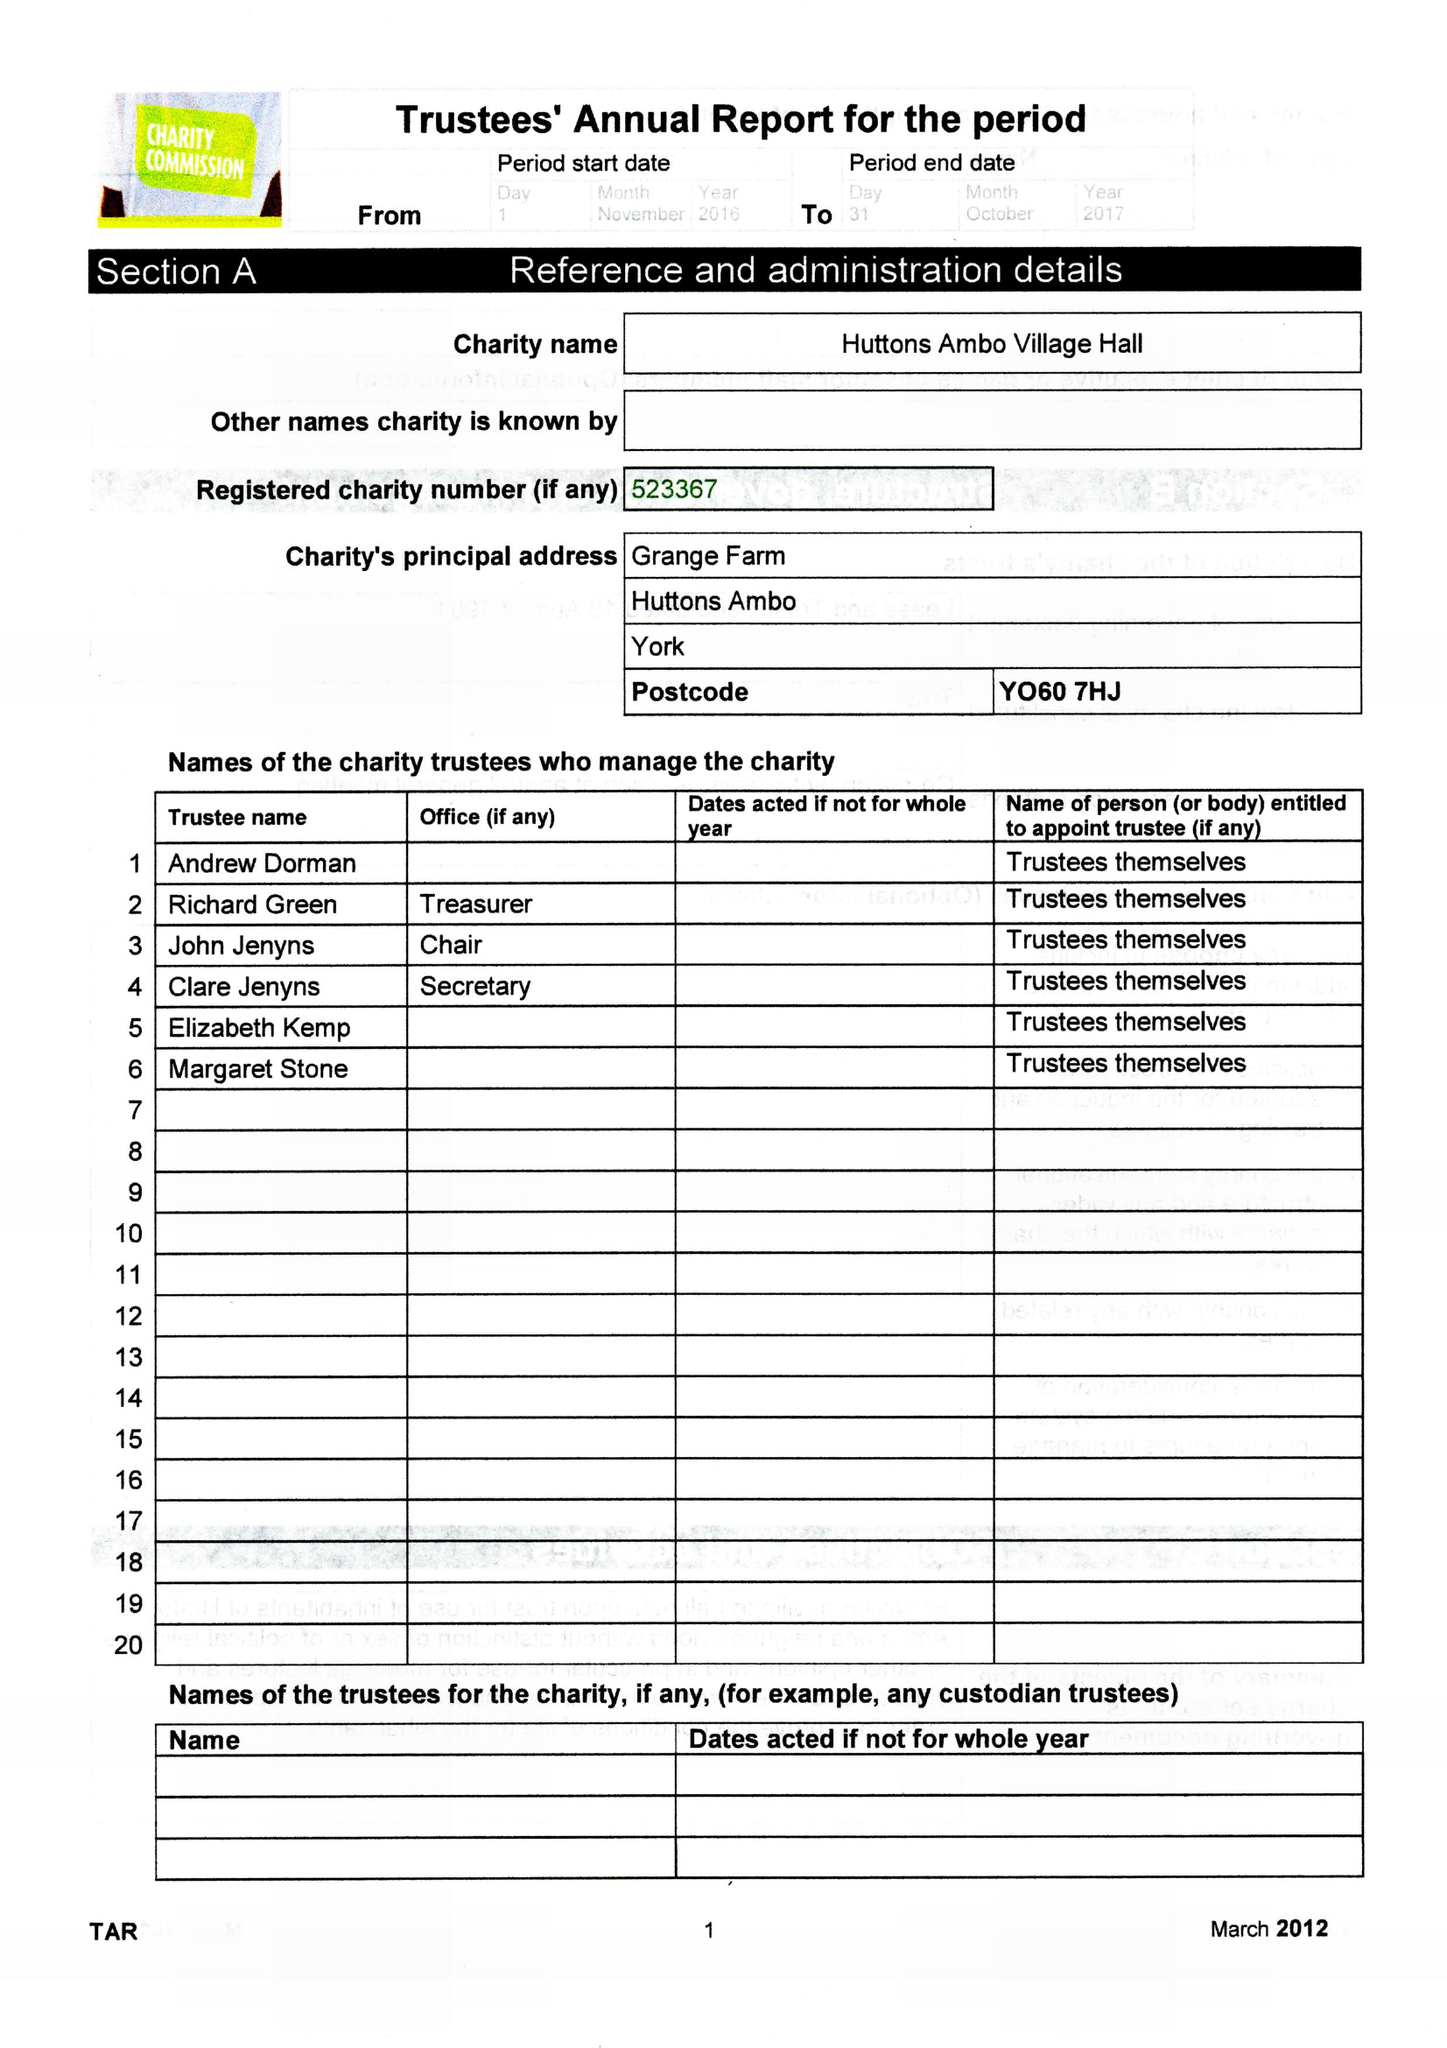What is the value for the address__postcode?
Answer the question using a single word or phrase. YO60 7HJ 